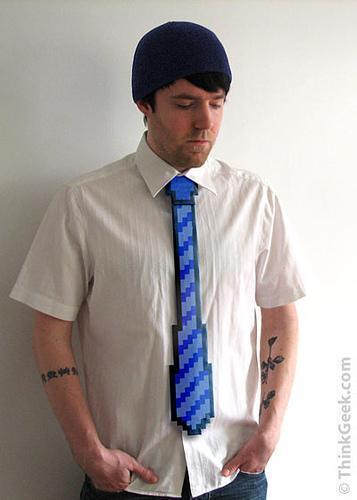How many bikes are here?
Give a very brief answer. 0. 